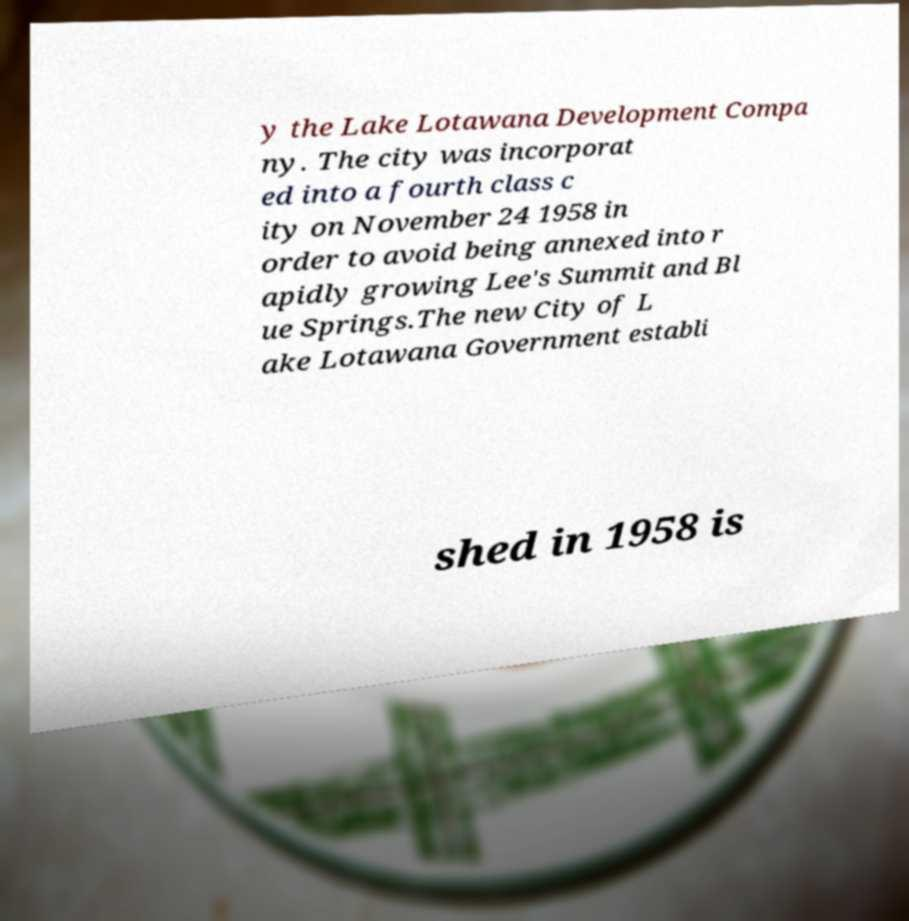Could you assist in decoding the text presented in this image and type it out clearly? y the Lake Lotawana Development Compa ny. The city was incorporat ed into a fourth class c ity on November 24 1958 in order to avoid being annexed into r apidly growing Lee's Summit and Bl ue Springs.The new City of L ake Lotawana Government establi shed in 1958 is 